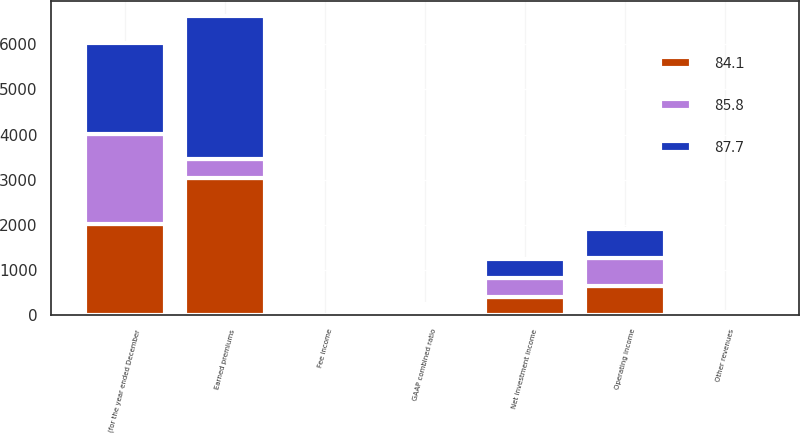Convert chart. <chart><loc_0><loc_0><loc_500><loc_500><stacked_bar_chart><ecel><fcel>(for the year ended December<fcel>Earned premiums<fcel>Net investment income<fcel>Fee income<fcel>Other revenues<fcel>Operating income<fcel>GAAP combined ratio<nl><fcel>84.1<fcel>2012<fcel>3045<fcel>395<fcel>1<fcel>26<fcel>642<fcel>84.1<nl><fcel>87.7<fcel>2011<fcel>3174<fcel>414<fcel>1<fcel>26<fcel>647<fcel>85.8<nl><fcel>85.8<fcel>2010<fcel>404.5<fcel>439<fcel>2<fcel>27<fcel>620<fcel>87.7<nl></chart> 